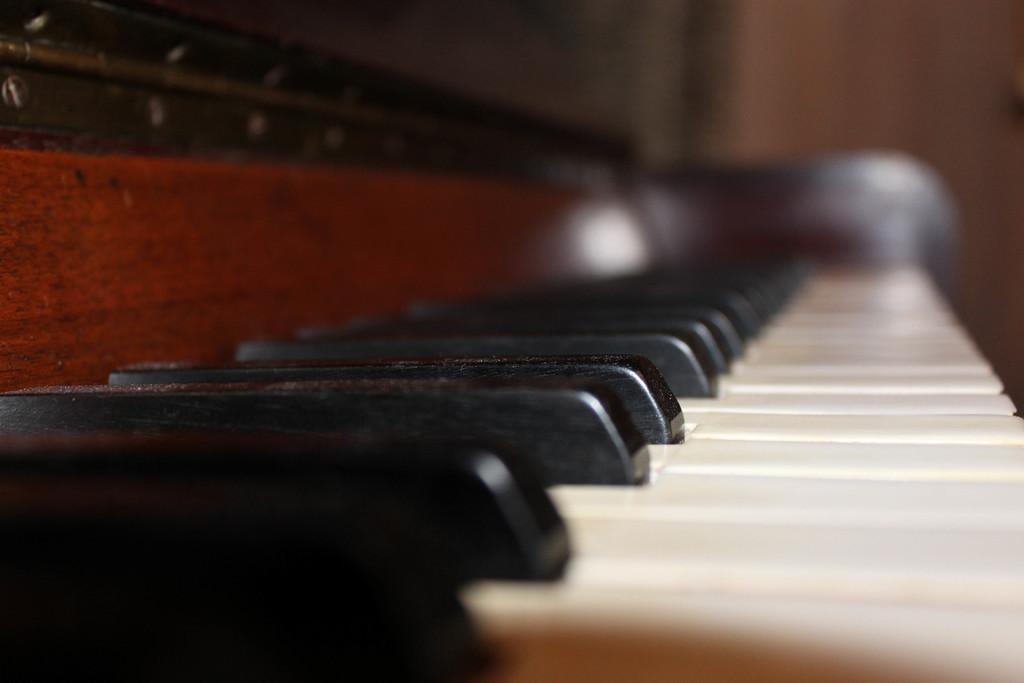What is the main object in the image? There is a piano in the image. What are the buttons on the piano called? The buttons on the piano are called keys. How many types of keys are there on the piano? There are two types of keys on the piano: black and white. What type of tank is visible in the image? There is no tank present in the image; it features a piano with black and white keys. How many stitches are required to fix the broken key on the piano? There is no broken key on the piano in the image, so no stitches are needed. 